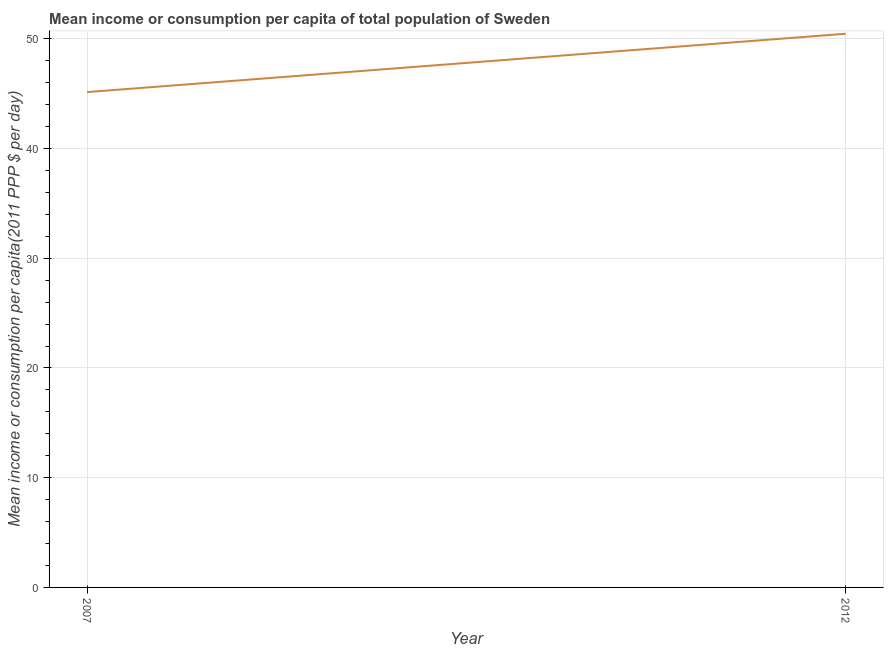What is the mean income or consumption in 2012?
Offer a very short reply. 50.46. Across all years, what is the maximum mean income or consumption?
Your response must be concise. 50.46. Across all years, what is the minimum mean income or consumption?
Your answer should be very brief. 45.14. What is the sum of the mean income or consumption?
Make the answer very short. 95.61. What is the difference between the mean income or consumption in 2007 and 2012?
Ensure brevity in your answer.  -5.32. What is the average mean income or consumption per year?
Offer a terse response. 47.8. What is the median mean income or consumption?
Your answer should be very brief. 47.8. In how many years, is the mean income or consumption greater than 48 $?
Your response must be concise. 1. What is the ratio of the mean income or consumption in 2007 to that in 2012?
Make the answer very short. 0.89. Is the mean income or consumption in 2007 less than that in 2012?
Provide a short and direct response. Yes. Does the mean income or consumption monotonically increase over the years?
Make the answer very short. Yes. How many lines are there?
Offer a very short reply. 1. How many years are there in the graph?
Make the answer very short. 2. What is the title of the graph?
Make the answer very short. Mean income or consumption per capita of total population of Sweden. What is the label or title of the X-axis?
Your response must be concise. Year. What is the label or title of the Y-axis?
Provide a short and direct response. Mean income or consumption per capita(2011 PPP $ per day). What is the Mean income or consumption per capita(2011 PPP $ per day) in 2007?
Ensure brevity in your answer.  45.14. What is the Mean income or consumption per capita(2011 PPP $ per day) in 2012?
Give a very brief answer. 50.46. What is the difference between the Mean income or consumption per capita(2011 PPP $ per day) in 2007 and 2012?
Ensure brevity in your answer.  -5.32. What is the ratio of the Mean income or consumption per capita(2011 PPP $ per day) in 2007 to that in 2012?
Offer a terse response. 0.9. 